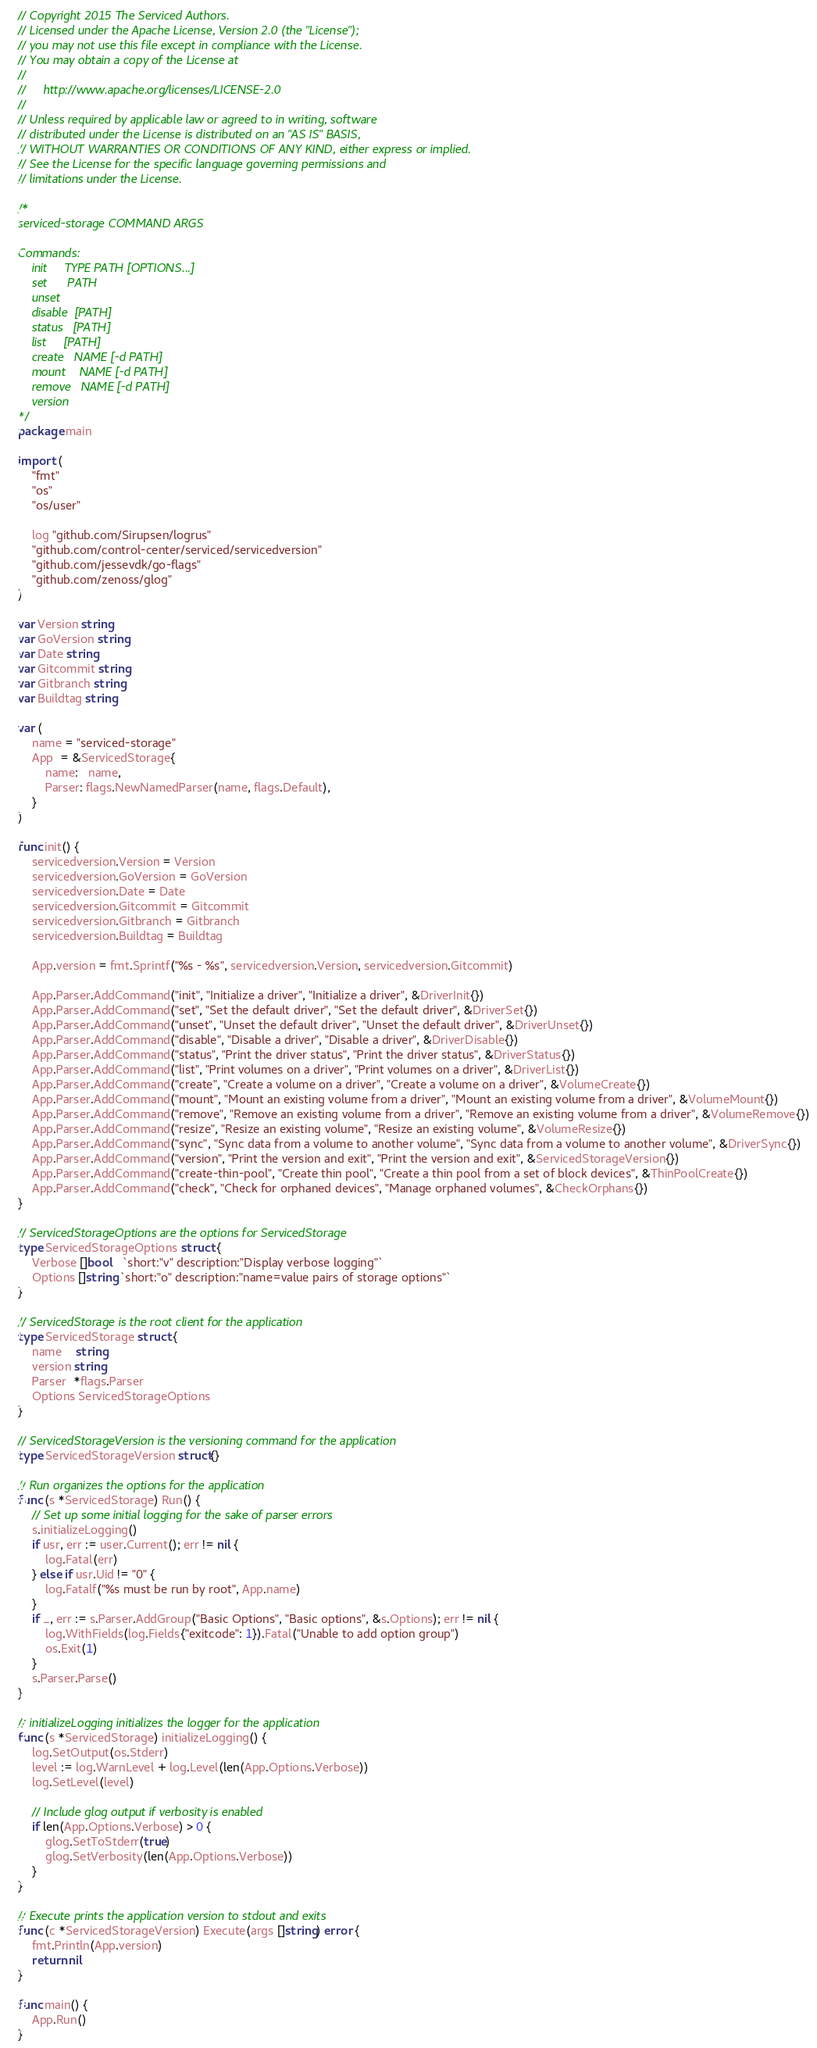<code> <loc_0><loc_0><loc_500><loc_500><_Go_>// Copyright 2015 The Serviced Authors.
// Licensed under the Apache License, Version 2.0 (the "License");
// you may not use this file except in compliance with the License.
// You may obtain a copy of the License at
//
//     http://www.apache.org/licenses/LICENSE-2.0
//
// Unless required by applicable law or agreed to in writing, software
// distributed under the License is distributed on an "AS IS" BASIS,
// WITHOUT WARRANTIES OR CONDITIONS OF ANY KIND, either express or implied.
// See the License for the specific language governing permissions and
// limitations under the License.

/*
serviced-storage COMMAND ARGS

Commands:
	init     TYPE PATH [OPTIONS...]
	set      PATH
	unset
	disable  [PATH]
	status   [PATH]
	list     [PATH]
	create   NAME [-d PATH]
	mount    NAME [-d PATH]
	remove   NAME [-d PATH]
	version
*/
package main

import (
	"fmt"
	"os"
	"os/user"

	log "github.com/Sirupsen/logrus"
	"github.com/control-center/serviced/servicedversion"
	"github.com/jessevdk/go-flags"
	"github.com/zenoss/glog"
)

var Version string
var GoVersion string
var Date string
var Gitcommit string
var Gitbranch string
var Buildtag string

var (
	name = "serviced-storage"
	App  = &ServicedStorage{
		name:   name,
		Parser: flags.NewNamedParser(name, flags.Default),
	}
)

func init() {
	servicedversion.Version = Version
	servicedversion.GoVersion = GoVersion
	servicedversion.Date = Date
	servicedversion.Gitcommit = Gitcommit
	servicedversion.Gitbranch = Gitbranch
	servicedversion.Buildtag = Buildtag

	App.version = fmt.Sprintf("%s - %s", servicedversion.Version, servicedversion.Gitcommit)

	App.Parser.AddCommand("init", "Initialize a driver", "Initialize a driver", &DriverInit{})
	App.Parser.AddCommand("set", "Set the default driver", "Set the default driver", &DriverSet{})
	App.Parser.AddCommand("unset", "Unset the default driver", "Unset the default driver", &DriverUnset{})
	App.Parser.AddCommand("disable", "Disable a driver", "Disable a driver", &DriverDisable{})
	App.Parser.AddCommand("status", "Print the driver status", "Print the driver status", &DriverStatus{})
	App.Parser.AddCommand("list", "Print volumes on a driver", "Print volumes on a driver", &DriverList{})
	App.Parser.AddCommand("create", "Create a volume on a driver", "Create a volume on a driver", &VolumeCreate{})
	App.Parser.AddCommand("mount", "Mount an existing volume from a driver", "Mount an existing volume from a driver", &VolumeMount{})
	App.Parser.AddCommand("remove", "Remove an existing volume from a driver", "Remove an existing volume from a driver", &VolumeRemove{})
	App.Parser.AddCommand("resize", "Resize an existing volume", "Resize an existing volume", &VolumeResize{})
	App.Parser.AddCommand("sync", "Sync data from a volume to another volume", "Sync data from a volume to another volume", &DriverSync{})
	App.Parser.AddCommand("version", "Print the version and exit", "Print the version and exit", &ServicedStorageVersion{})
	App.Parser.AddCommand("create-thin-pool", "Create thin pool", "Create a thin pool from a set of block devices", &ThinPoolCreate{})
	App.Parser.AddCommand("check", "Check for orphaned devices", "Manage orphaned volumes", &CheckOrphans{})
}

// ServicedStorageOptions are the options for ServicedStorage
type ServicedStorageOptions struct {
	Verbose []bool   `short:"v" description:"Display verbose logging"`
	Options []string `short:"o" description:"name=value pairs of storage options"`
}

// ServicedStorage is the root client for the application
type ServicedStorage struct {
	name    string
	version string
	Parser  *flags.Parser
	Options ServicedStorageOptions
}

// ServicedStorageVersion is the versioning command for the application
type ServicedStorageVersion struct{}

// Run organizes the options for the application
func (s *ServicedStorage) Run() {
	// Set up some initial logging for the sake of parser errors
	s.initializeLogging()
	if usr, err := user.Current(); err != nil {
		log.Fatal(err)
	} else if usr.Uid != "0" {
		log.Fatalf("%s must be run by root", App.name)
	}
	if _, err := s.Parser.AddGroup("Basic Options", "Basic options", &s.Options); err != nil {
		log.WithFields(log.Fields{"exitcode": 1}).Fatal("Unable to add option group")
		os.Exit(1)
	}
	s.Parser.Parse()
}

// initializeLogging initializes the logger for the application
func (s *ServicedStorage) initializeLogging() {
	log.SetOutput(os.Stderr)
	level := log.WarnLevel + log.Level(len(App.Options.Verbose))
	log.SetLevel(level)

	// Include glog output if verbosity is enabled
	if len(App.Options.Verbose) > 0 {
		glog.SetToStderr(true)
		glog.SetVerbosity(len(App.Options.Verbose))
	}
}

// Execute prints the application version to stdout and exits
func (c *ServicedStorageVersion) Execute(args []string) error {
	fmt.Println(App.version)
	return nil
}

func main() {
	App.Run()
}
</code> 